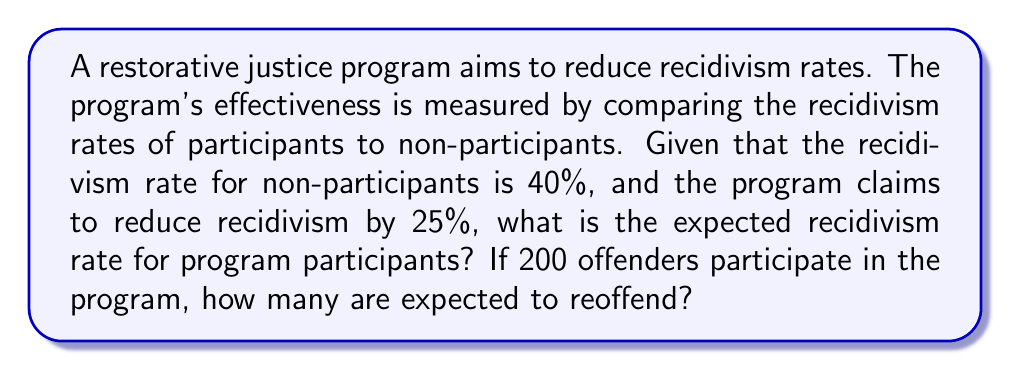What is the answer to this math problem? 1. Define the initial recidivism rate:
   $R_0 = 40\% = 0.40$

2. Calculate the reduction factor:
   Reduction = 25% = 0.25
   Reduction factor = $1 - 0.25 = 0.75$

3. Calculate the new recidivism rate for program participants:
   $R_1 = R_0 \times \text{Reduction factor}$
   $R_1 = 0.40 \times 0.75 = 0.30 = 30\%$

4. Calculate the number of participants expected to reoffend:
   Total participants = 200
   Expected reoffenders = $200 \times R_1 = 200 \times 0.30 = 60$

To solve the inverse problem of estimating program effectiveness:
   Effectiveness = $1 - \frac{R_1}{R_0} = 1 - \frac{0.30}{0.40} = 0.25 = 25\%$

This confirms the claimed 25% reduction in recidivism rates.
Answer: 30% recidivism rate; 60 expected reoffenders 